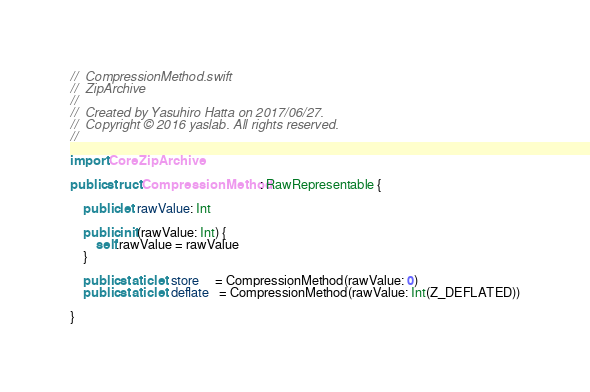Convert code to text. <code><loc_0><loc_0><loc_500><loc_500><_Swift_>//  CompressionMethod.swift
//  ZipArchive
//
//  Created by Yasuhiro Hatta on 2017/06/27.
//  Copyright © 2016 yaslab. All rights reserved.
//

import CoreZipArchive

public struct CompressionMethod: RawRepresentable {
    
    public let rawValue: Int
    
    public init(rawValue: Int) {
        self.rawValue = rawValue
    }
    
    public static let store     = CompressionMethod(rawValue: 0)
    public static let deflate   = CompressionMethod(rawValue: Int(Z_DEFLATED))
    
}
</code> 